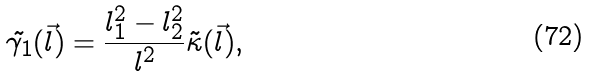Convert formula to latex. <formula><loc_0><loc_0><loc_500><loc_500>\tilde { \gamma _ { 1 } } ( \vec { l } ) = \frac { l _ { 1 } ^ { 2 } - l _ { 2 } ^ { 2 } } { l ^ { 2 } } \tilde { \kappa } ( \vec { l } ) ,</formula> 